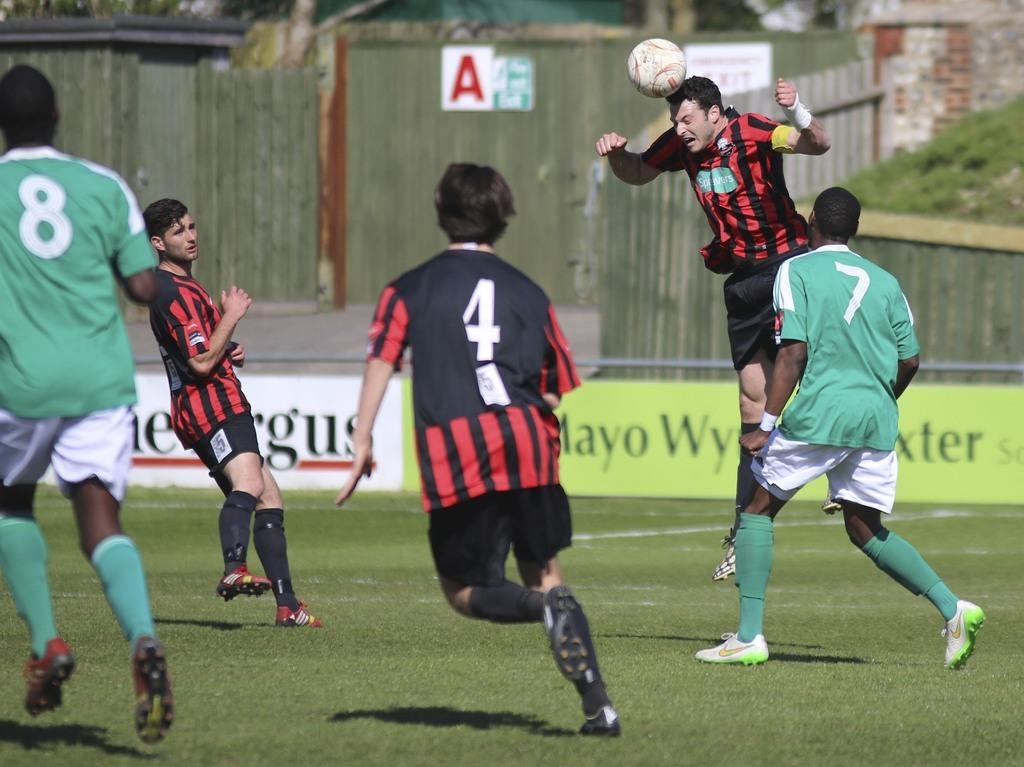What are the people in the image doing? The people in the image are playing in the ground. Can you describe the action of the man in the image? The man is jumping in the image. What is on the man's head? There is a ball on the man's head. What can be seen in the background of the image? There is a fence and a house in the background of the image. What type of lamp is being used by the man's grandfather in the image? There is no lamp or grandfather present in the image. 